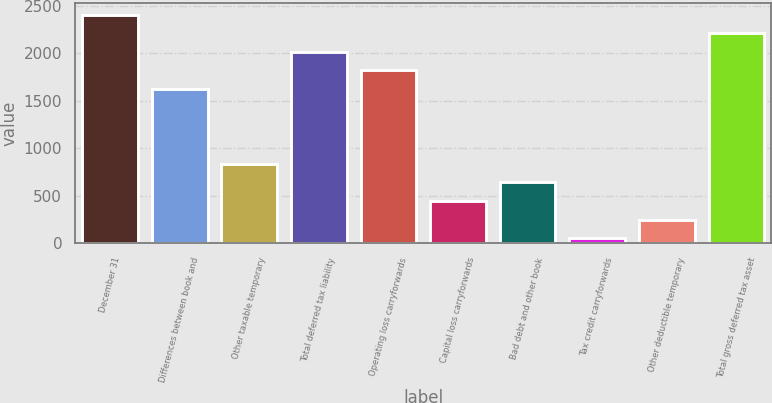Convert chart. <chart><loc_0><loc_0><loc_500><loc_500><bar_chart><fcel>December 31<fcel>Differences between book and<fcel>Other taxable temporary<fcel>Total deferred tax liability<fcel>Operating loss carryforwards<fcel>Capital loss carryforwards<fcel>Bad debt and other book<fcel>Tax credit carryforwards<fcel>Other deductible temporary<fcel>Total gross deferred tax asset<nl><fcel>2410.2<fcel>1623.8<fcel>837.4<fcel>2017<fcel>1820.4<fcel>444.2<fcel>640.8<fcel>51<fcel>247.6<fcel>2213.6<nl></chart> 